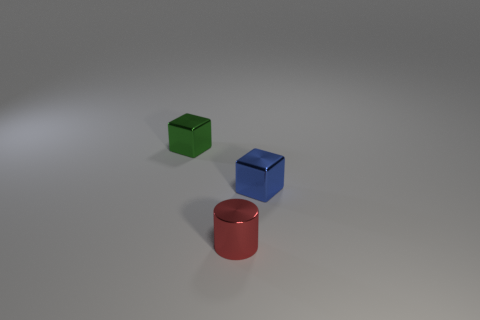How many other objects are the same material as the blue thing?
Ensure brevity in your answer.  2. The thing that is behind the small red shiny thing and on the left side of the tiny blue shiny thing is what color?
Your response must be concise. Green. How many objects are blocks on the left side of the red cylinder or yellow metal cylinders?
Your answer should be compact. 1. What number of other things are the same color as the small cylinder?
Your answer should be compact. 0. Are there the same number of blocks that are to the right of the red thing and red things?
Offer a very short reply. Yes. What number of small green metal cubes are behind the cube that is to the right of the tiny thing left of the red shiny object?
Provide a short and direct response. 1. Is there any other thing that is the same size as the cylinder?
Ensure brevity in your answer.  Yes. There is a red thing; does it have the same size as the thing behind the blue thing?
Provide a succinct answer. Yes. How many brown blocks are there?
Your response must be concise. 0. There is a metallic thing right of the metal cylinder; is its size the same as the cylinder that is in front of the tiny green thing?
Your response must be concise. Yes. 